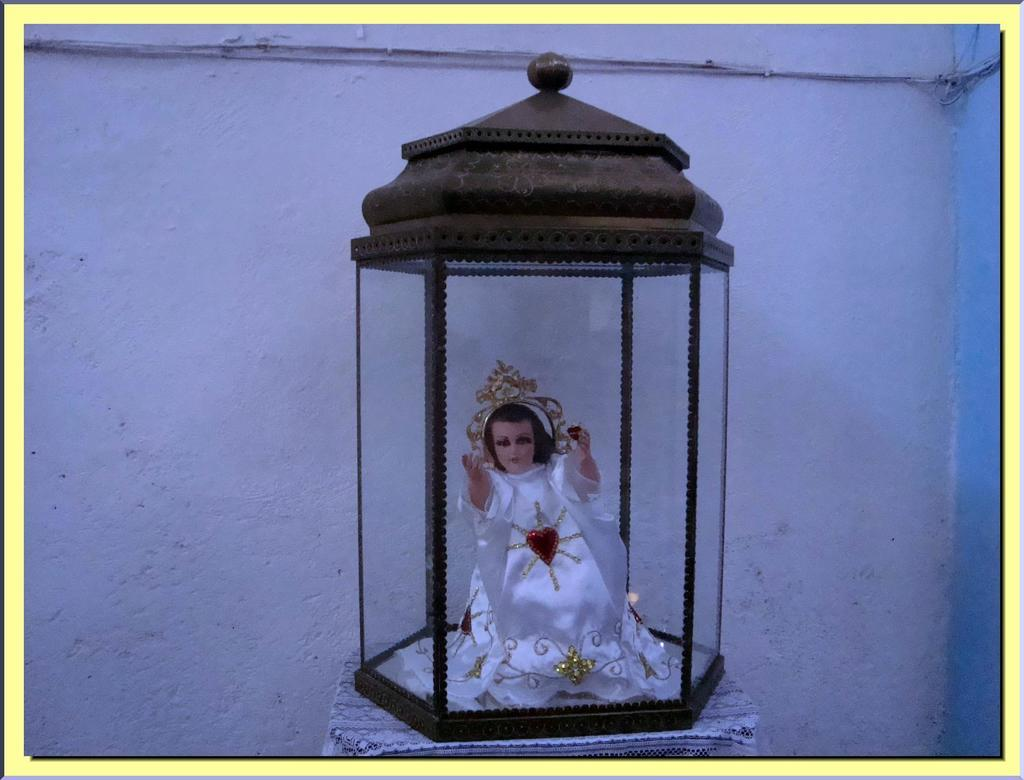What is placed on the side table in the image? There is a decoration on a side table in the image. What type of horse can be seen walking down the street in the image? There is no horse or street present in the image; it only features a decoration on a side table. 